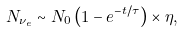<formula> <loc_0><loc_0><loc_500><loc_500>N _ { \nu _ { e } } \sim N _ { 0 } \left ( 1 - e ^ { - t / \tau } \right ) \times \eta ,</formula> 